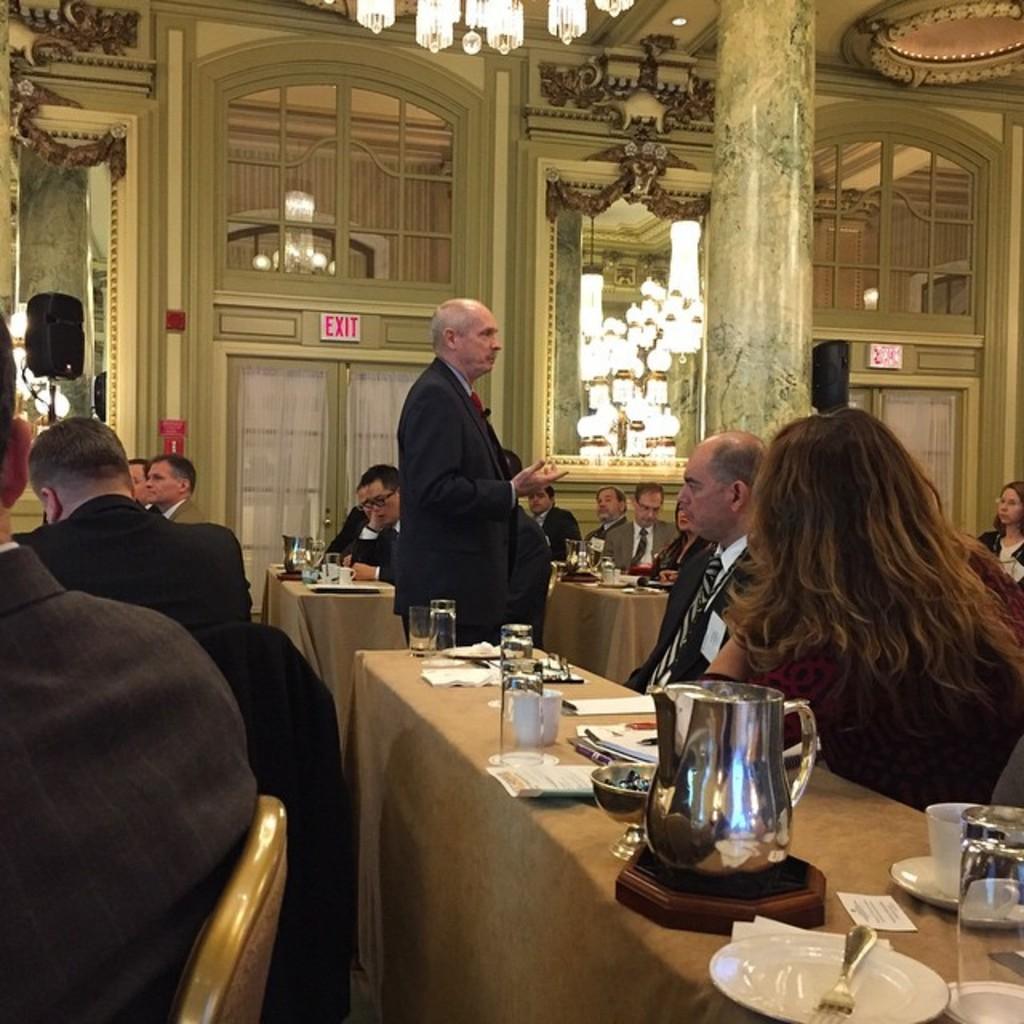Please provide a concise description of this image. In this image I can see in the middle a man is standing, he wore coat. On the right side a woman is sitting near the dining table and there are food items, plates, jug, water glasses on this table. On the left side few men are also sitting. In the middle there is a mirror, at the top there are lights. 